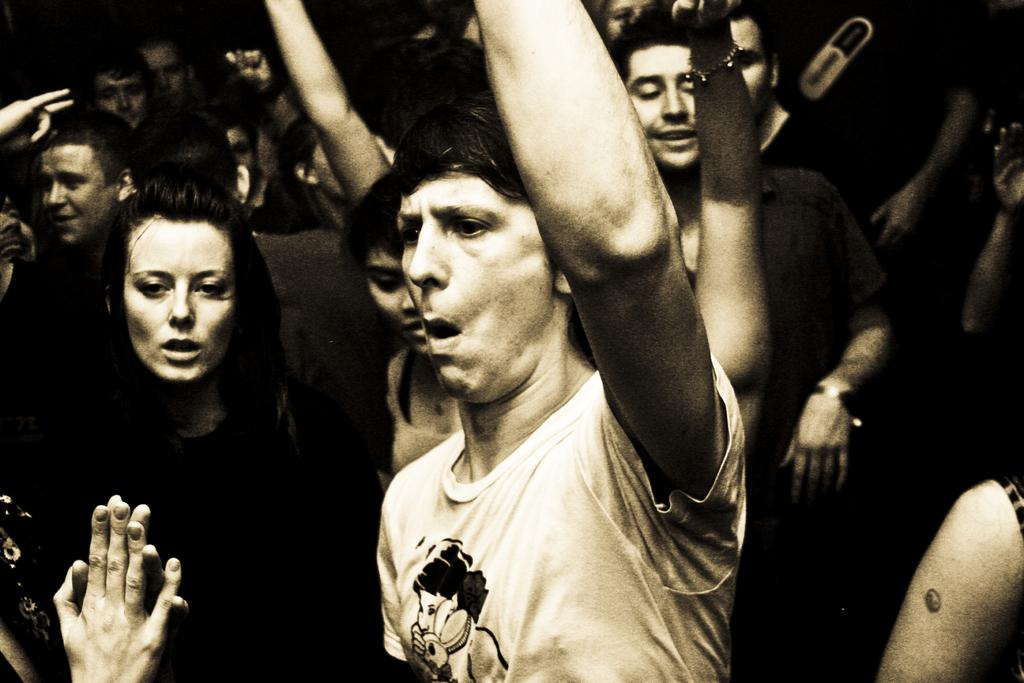How many people are in the image? There are people in the image, but the exact number is not specified. What are the people doing in the image? The people are standing in a place, shouting something, and raising their hands in the air. Can you describe the actions of the people in the image? The people are standing, shouting, and raising their hands in the air. What is the price of the hospital in the image? There is no hospital present in the image, so it is not possible to determine its price. 